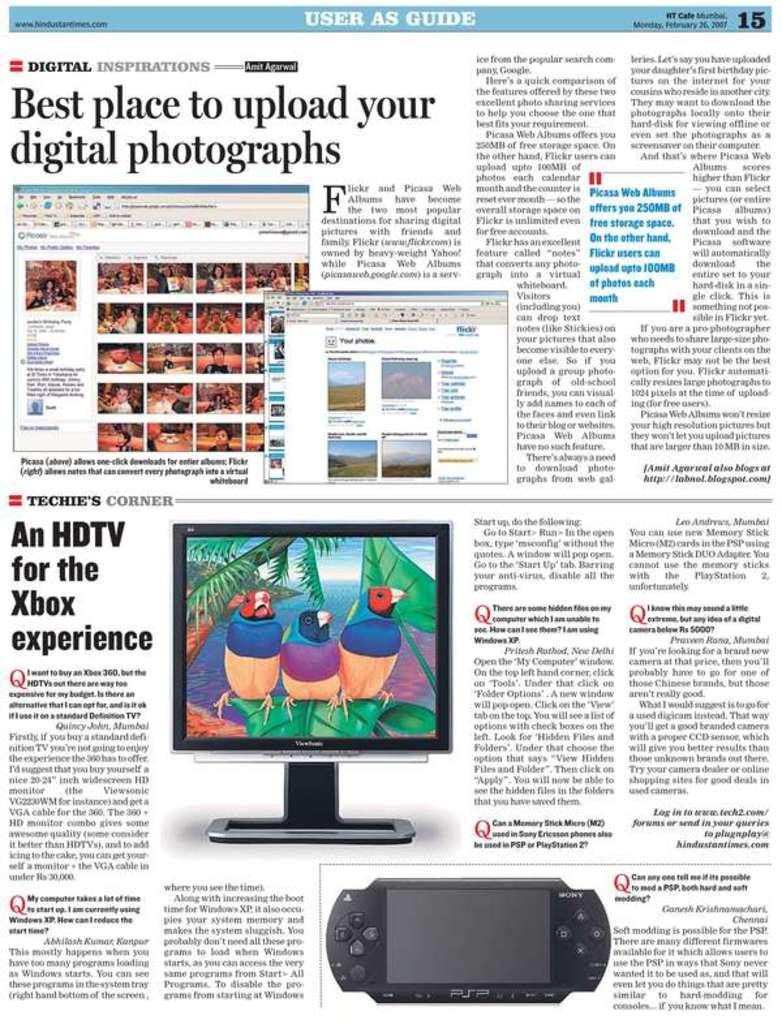In one or two sentences, can you explain what this image depicts? In this picture there is a newspaper column. At the bottom there are monitor, playstation and text. At the top there are text and dialogue boxes. 